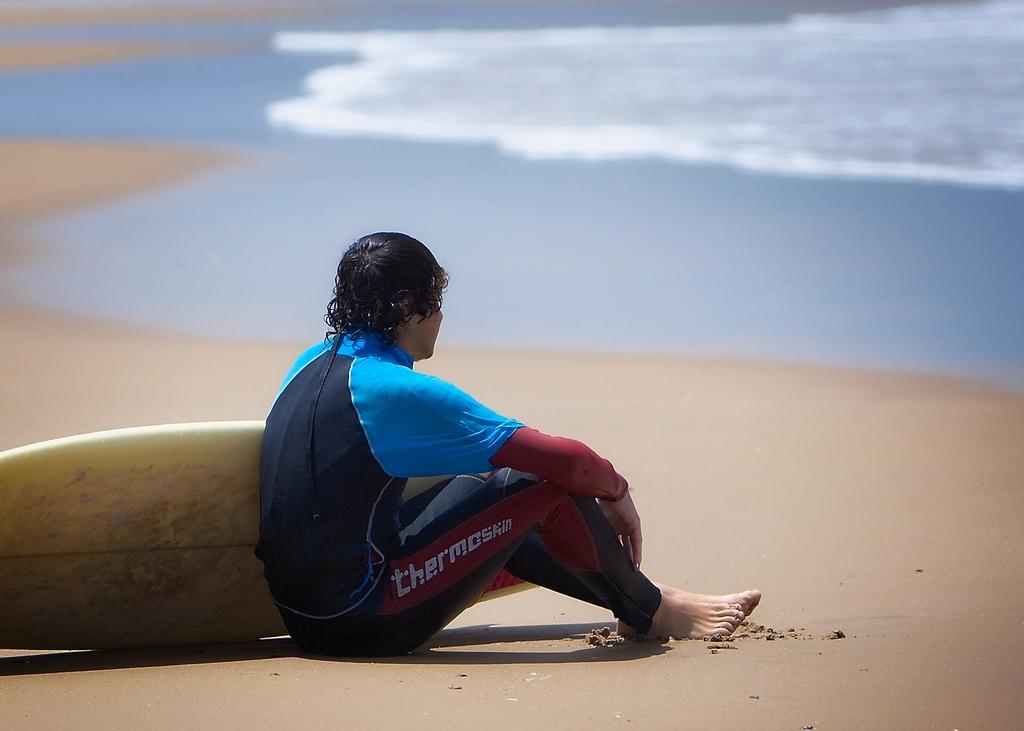How would you summarize this image in a sentence or two? In the center of the image there is a person with surfboard sitting on the sand. In the background there is a water. 